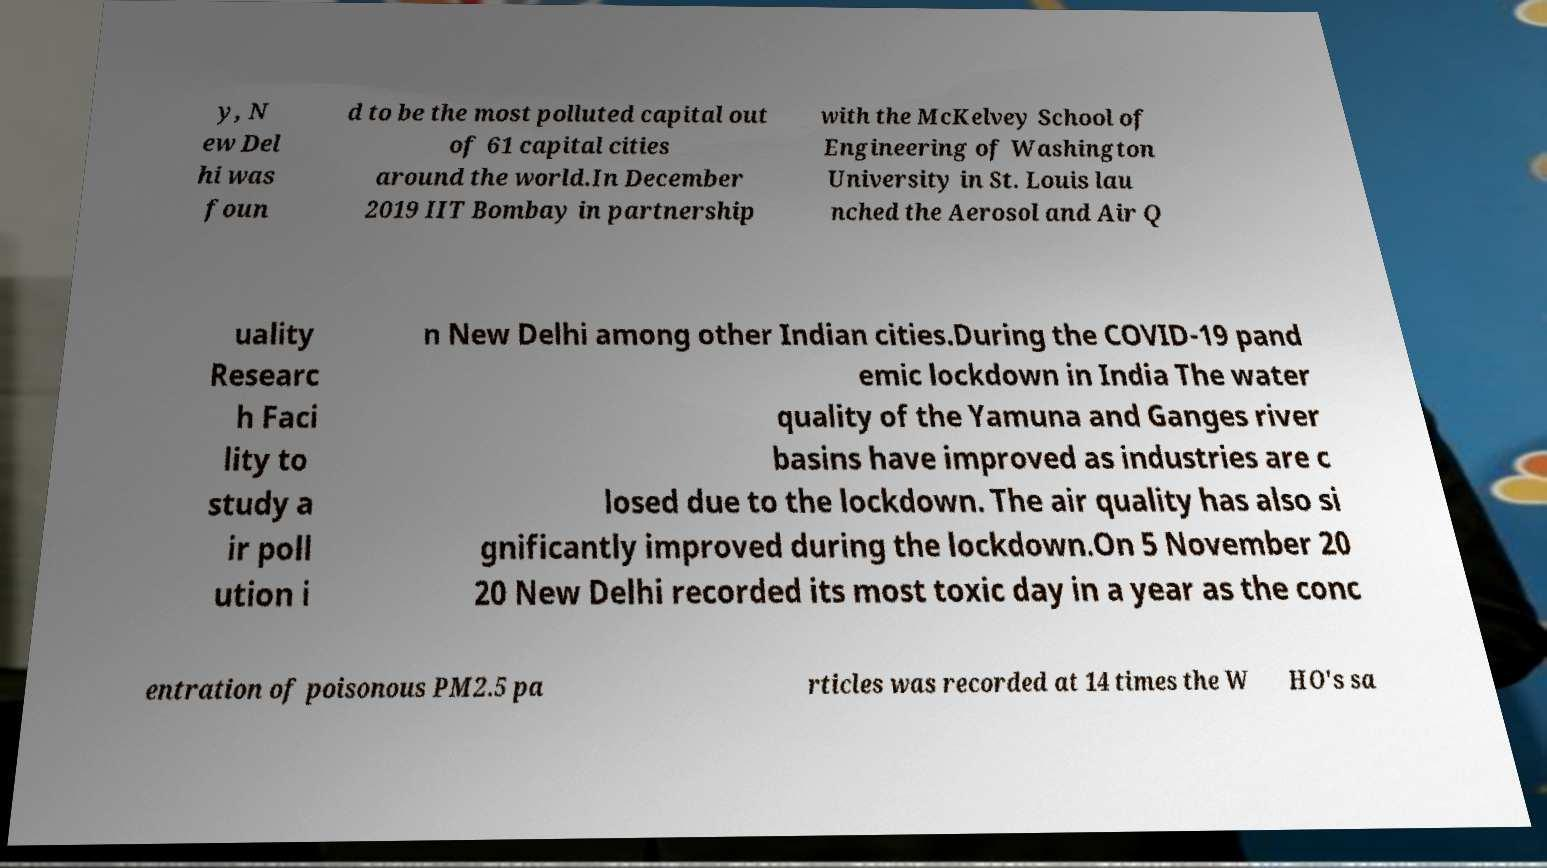Please identify and transcribe the text found in this image. y, N ew Del hi was foun d to be the most polluted capital out of 61 capital cities around the world.In December 2019 IIT Bombay in partnership with the McKelvey School of Engineering of Washington University in St. Louis lau nched the Aerosol and Air Q uality Researc h Faci lity to study a ir poll ution i n New Delhi among other Indian cities.During the COVID-19 pand emic lockdown in India The water quality of the Yamuna and Ganges river basins have improved as industries are c losed due to the lockdown. The air quality has also si gnificantly improved during the lockdown.On 5 November 20 20 New Delhi recorded its most toxic day in a year as the conc entration of poisonous PM2.5 pa rticles was recorded at 14 times the W HO's sa 